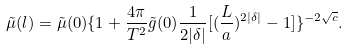<formula> <loc_0><loc_0><loc_500><loc_500>\tilde { \mu } ( l ) = \tilde { \mu } ( 0 ) \{ 1 + \frac { 4 \pi } { T ^ { 2 } } \tilde { g } ( 0 ) \frac { 1 } { 2 | \delta | } [ ( \frac { L } { a } ) ^ { 2 | \delta | } - 1 ] \} ^ { - 2 \sqrt { c } } .</formula> 